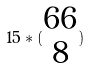Convert formula to latex. <formula><loc_0><loc_0><loc_500><loc_500>1 5 * ( \begin{matrix} 6 6 \\ 8 \end{matrix} )</formula> 